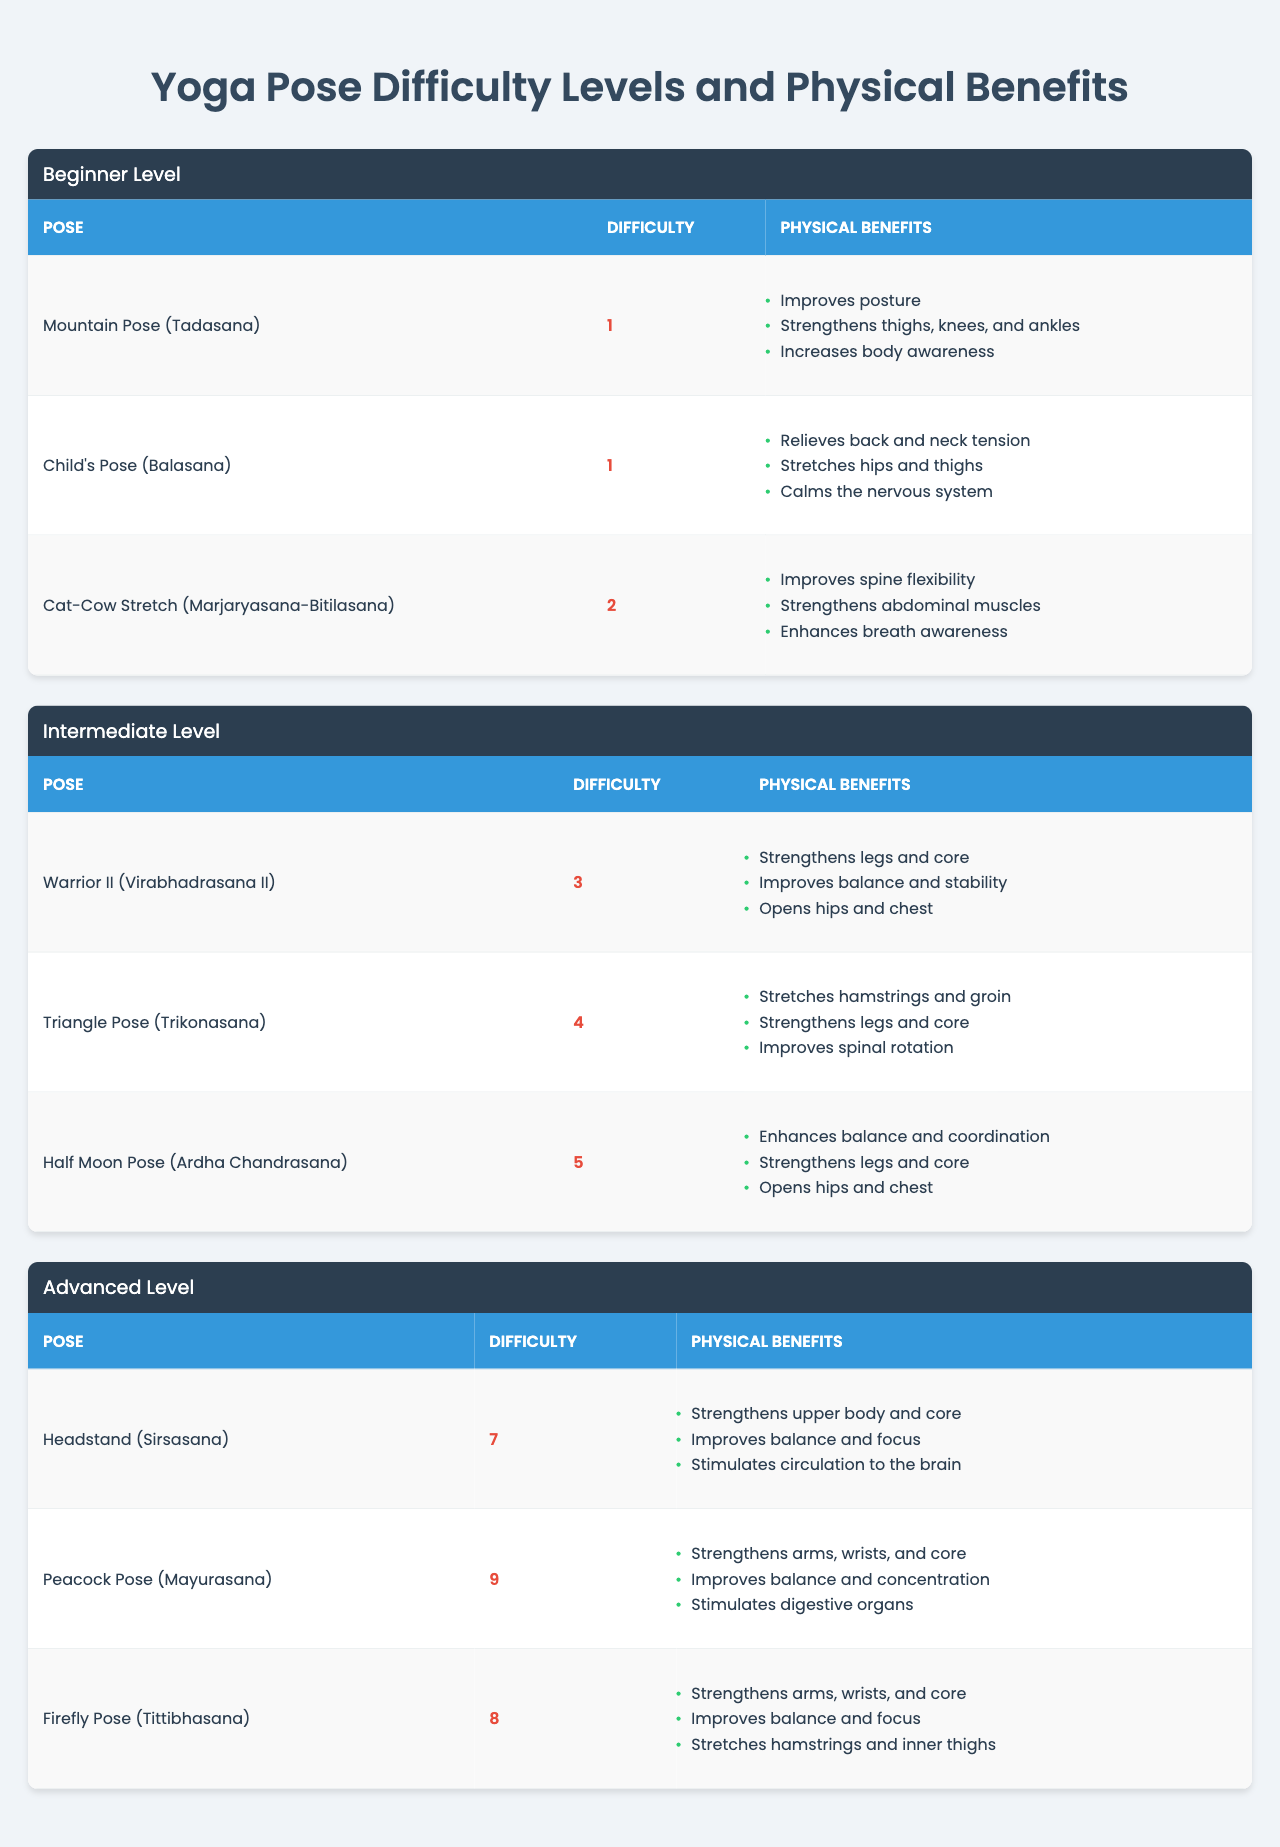What is the difficulty level of Warrior II pose? According to the table, the Warrior II pose has a difficulty level of 3.
Answer: 3 Which yoga pose has the most physical benefits? The Half Moon Pose has three physical benefits listed, which is the highest among the poses in the table.
Answer: Half Moon Pose Is the Cat-Cow Stretch easier or harder than the Triangle Pose? The Cat-Cow Stretch has a difficulty level of 2, while the Triangle Pose has a difficulty level of 4, indicating that Cat-Cow is easier.
Answer: Easier What are the physical benefits of the Peacock Pose? The Peacock Pose has three physical benefits: it strengthens arms, wrists, and core; improves balance and concentration; and stimulates digestive organs.
Answer: Strengthens arms, wrists, core; improves balance; stimulates digestive organs How many poses have a difficulty level of 5 or higher? There are three poses with a difficulty level of 5 or higher: Half Moon Pose, Firefly Pose, and Peacock Pose.
Answer: 3 Is it true that all advanced poses have a difficulty level greater than 6? Yes, all advanced poses (Headstand, Peacock Pose, and Firefly Pose) have difficulty levels of 7, 9, and 8, respectively, meaning they are all greater than 6.
Answer: True What is the sum of the difficulty levels for all intermediate poses? The sum of the difficulty levels for intermediate poses is 3 (Warrior II) + 4 (Triangle Pose) + 5 (Half Moon Pose), which equals 12.
Answer: 12 Which beginner pose focuses on improving body awareness? The Mountain Pose (Tadasana) is specifically mentioned to improve body awareness among beginner poses.
Answer: Mountain Pose Among the advanced level poses, which one improves balance and focus? Both the Headstand and the Firefly Pose improve balance and focus, as noted in their physical benefits.
Answer: Headstand and Firefly Pose What is the average difficulty level of beginner poses? The difficulties of beginner poses are: 1 (Mountain Pose), 1 (Child's Pose), and 2 (Cat-Cow Stretch). Summing these gives 4, and dividing by 3 yields an average of approximately 1.33.
Answer: 1.33 